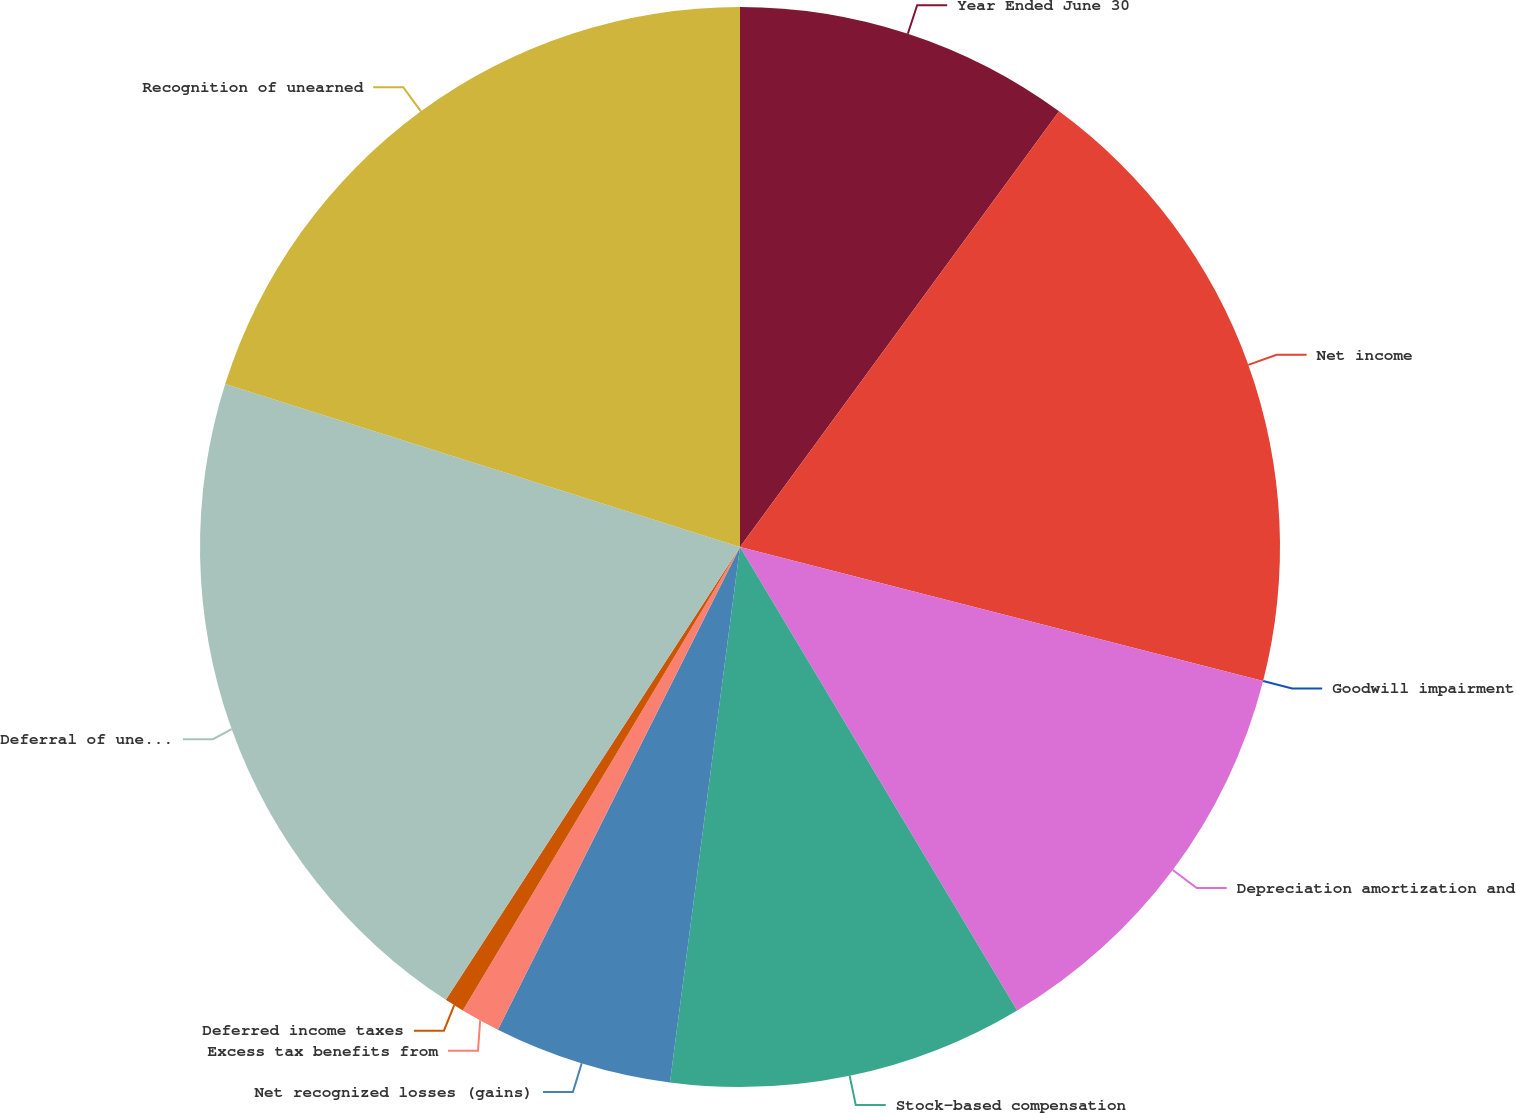<chart> <loc_0><loc_0><loc_500><loc_500><pie_chart><fcel>Year Ended June 30<fcel>Net income<fcel>Goodwill impairment<fcel>Depreciation amortization and<fcel>Stock-based compensation<fcel>Net recognized losses (gains)<fcel>Excess tax benefits from<fcel>Deferred income taxes<fcel>Deferral of unearned revenue<fcel>Recognition of unearned<nl><fcel>10.06%<fcel>18.93%<fcel>0.0%<fcel>12.43%<fcel>10.65%<fcel>5.33%<fcel>1.18%<fcel>0.59%<fcel>20.71%<fcel>20.12%<nl></chart> 